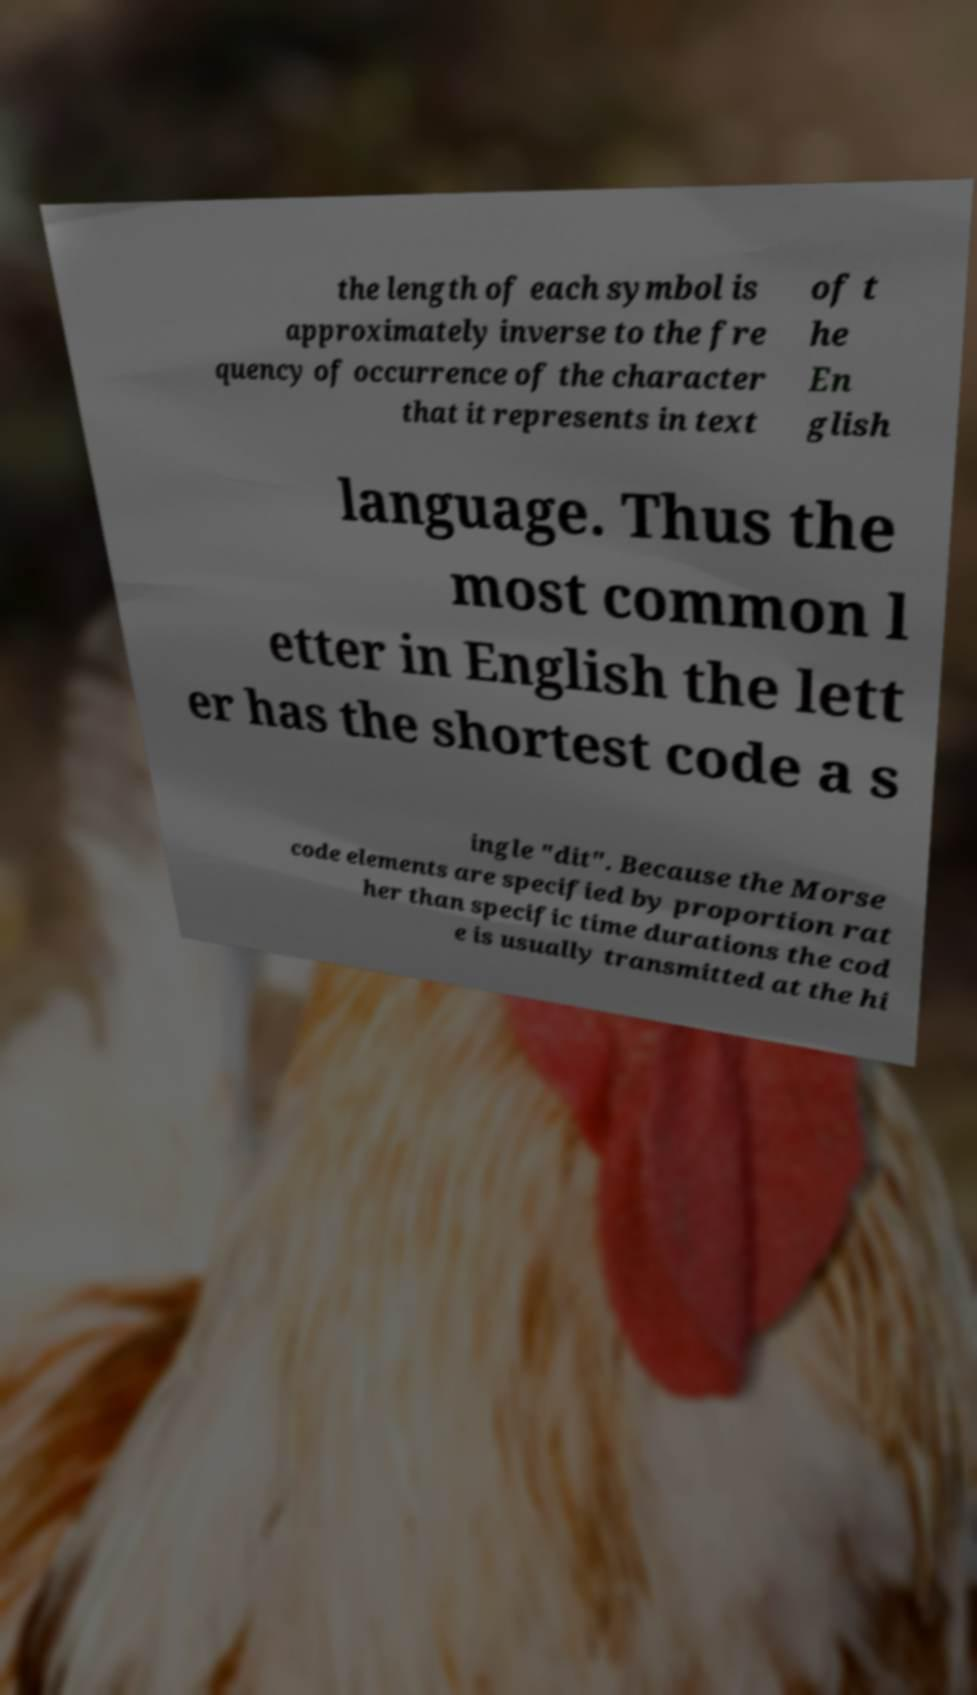Please identify and transcribe the text found in this image. the length of each symbol is approximately inverse to the fre quency of occurrence of the character that it represents in text of t he En glish language. Thus the most common l etter in English the lett er has the shortest code a s ingle "dit". Because the Morse code elements are specified by proportion rat her than specific time durations the cod e is usually transmitted at the hi 